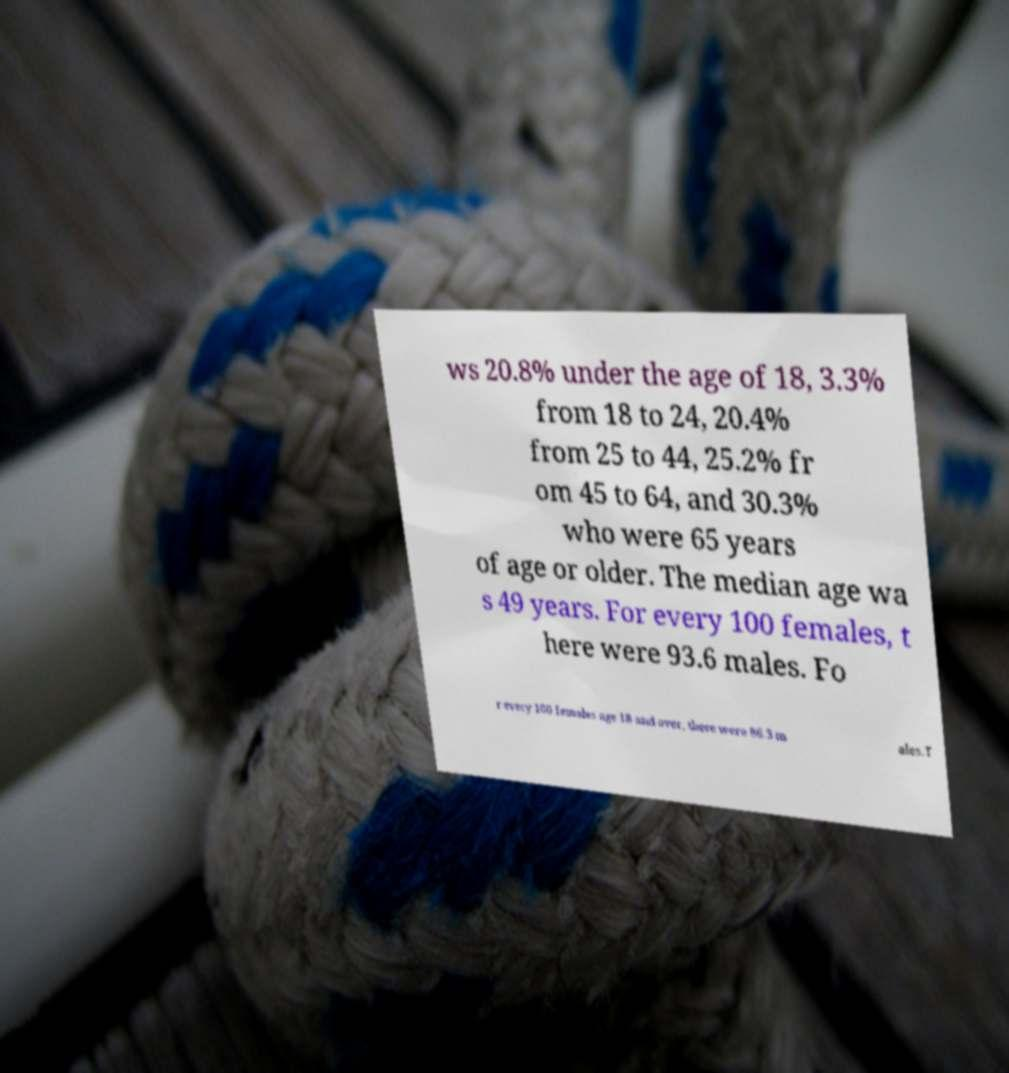Can you accurately transcribe the text from the provided image for me? ws 20.8% under the age of 18, 3.3% from 18 to 24, 20.4% from 25 to 44, 25.2% fr om 45 to 64, and 30.3% who were 65 years of age or older. The median age wa s 49 years. For every 100 females, t here were 93.6 males. Fo r every 100 females age 18 and over, there were 86.3 m ales.T 